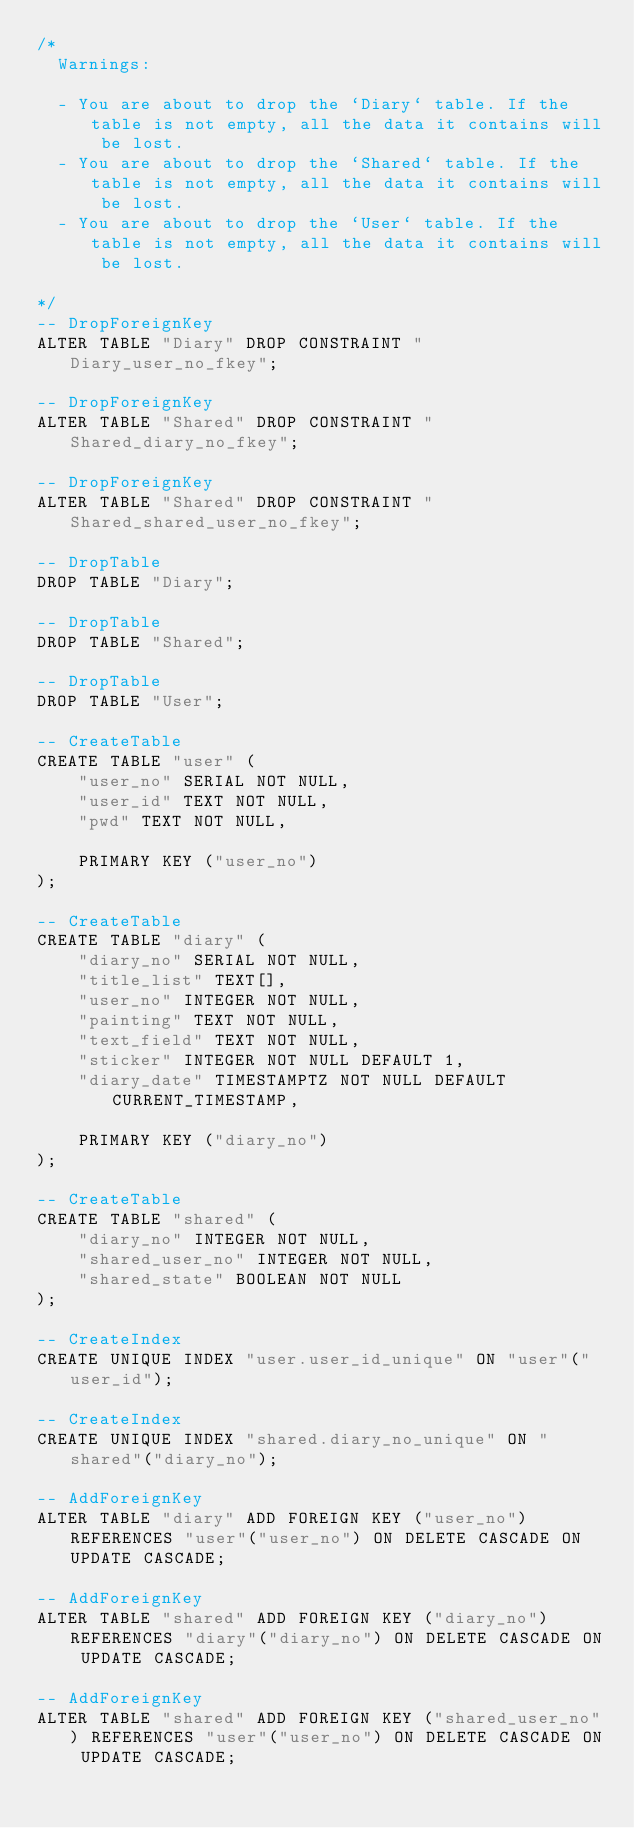Convert code to text. <code><loc_0><loc_0><loc_500><loc_500><_SQL_>/*
  Warnings:

  - You are about to drop the `Diary` table. If the table is not empty, all the data it contains will be lost.
  - You are about to drop the `Shared` table. If the table is not empty, all the data it contains will be lost.
  - You are about to drop the `User` table. If the table is not empty, all the data it contains will be lost.

*/
-- DropForeignKey
ALTER TABLE "Diary" DROP CONSTRAINT "Diary_user_no_fkey";

-- DropForeignKey
ALTER TABLE "Shared" DROP CONSTRAINT "Shared_diary_no_fkey";

-- DropForeignKey
ALTER TABLE "Shared" DROP CONSTRAINT "Shared_shared_user_no_fkey";

-- DropTable
DROP TABLE "Diary";

-- DropTable
DROP TABLE "Shared";

-- DropTable
DROP TABLE "User";

-- CreateTable
CREATE TABLE "user" (
    "user_no" SERIAL NOT NULL,
    "user_id" TEXT NOT NULL,
    "pwd" TEXT NOT NULL,

    PRIMARY KEY ("user_no")
);

-- CreateTable
CREATE TABLE "diary" (
    "diary_no" SERIAL NOT NULL,
    "title_list" TEXT[],
    "user_no" INTEGER NOT NULL,
    "painting" TEXT NOT NULL,
    "text_field" TEXT NOT NULL,
    "sticker" INTEGER NOT NULL DEFAULT 1,
    "diary_date" TIMESTAMPTZ NOT NULL DEFAULT CURRENT_TIMESTAMP,

    PRIMARY KEY ("diary_no")
);

-- CreateTable
CREATE TABLE "shared" (
    "diary_no" INTEGER NOT NULL,
    "shared_user_no" INTEGER NOT NULL,
    "shared_state" BOOLEAN NOT NULL
);

-- CreateIndex
CREATE UNIQUE INDEX "user.user_id_unique" ON "user"("user_id");

-- CreateIndex
CREATE UNIQUE INDEX "shared.diary_no_unique" ON "shared"("diary_no");

-- AddForeignKey
ALTER TABLE "diary" ADD FOREIGN KEY ("user_no") REFERENCES "user"("user_no") ON DELETE CASCADE ON UPDATE CASCADE;

-- AddForeignKey
ALTER TABLE "shared" ADD FOREIGN KEY ("diary_no") REFERENCES "diary"("diary_no") ON DELETE CASCADE ON UPDATE CASCADE;

-- AddForeignKey
ALTER TABLE "shared" ADD FOREIGN KEY ("shared_user_no") REFERENCES "user"("user_no") ON DELETE CASCADE ON UPDATE CASCADE;
</code> 